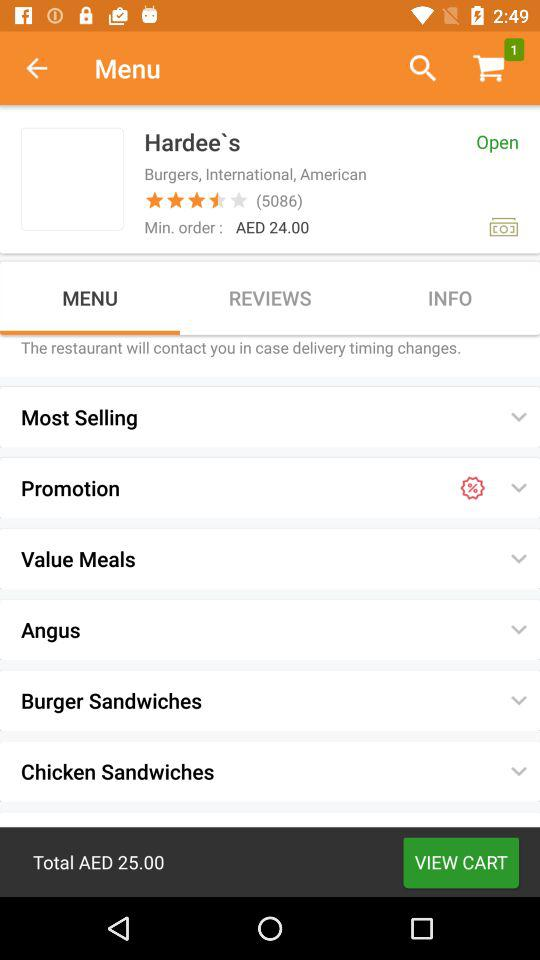What should be the Minimum Order Cost? The Minimum Order Cost is AED 24.00. 